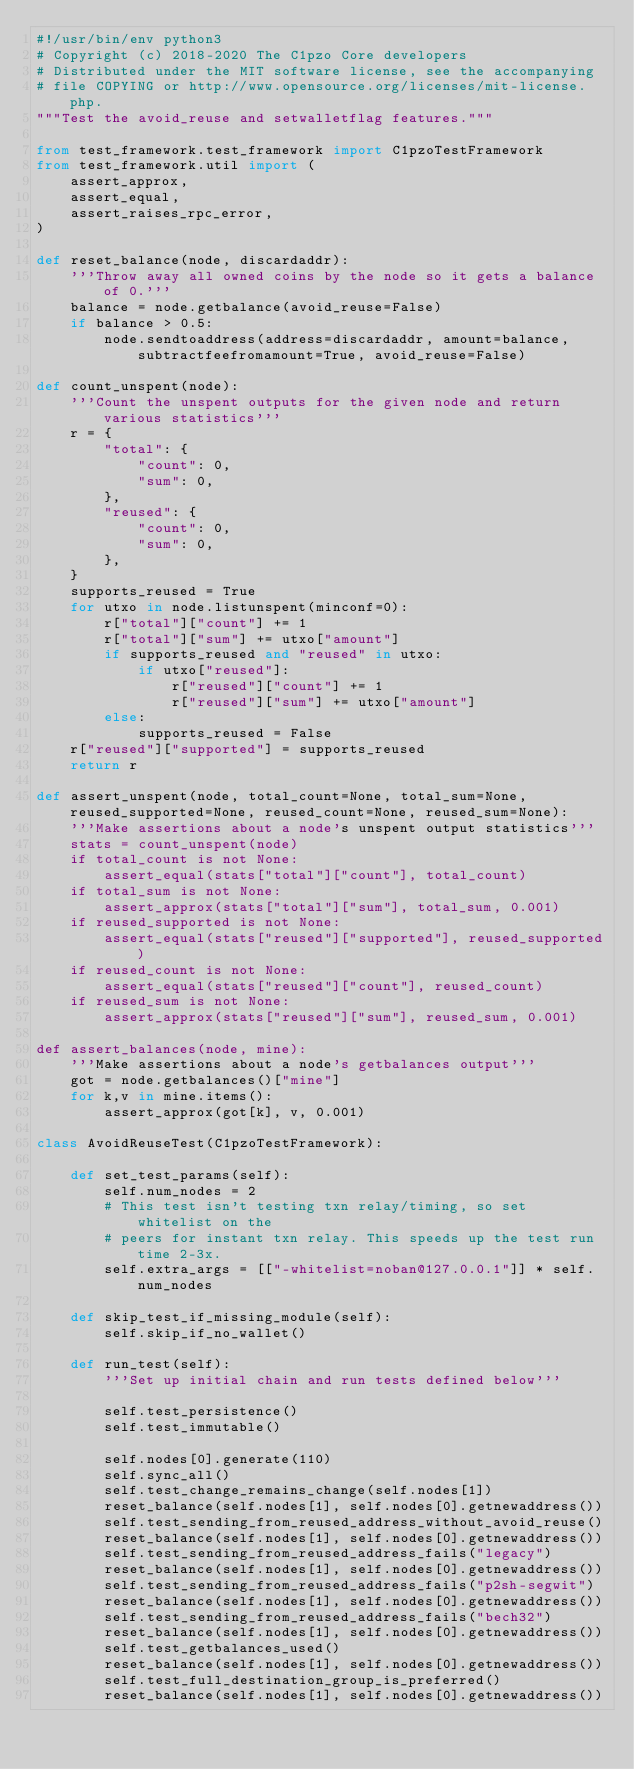<code> <loc_0><loc_0><loc_500><loc_500><_Python_>#!/usr/bin/env python3
# Copyright (c) 2018-2020 The C1pzo Core developers
# Distributed under the MIT software license, see the accompanying
# file COPYING or http://www.opensource.org/licenses/mit-license.php.
"""Test the avoid_reuse and setwalletflag features."""

from test_framework.test_framework import C1pzoTestFramework
from test_framework.util import (
    assert_approx,
    assert_equal,
    assert_raises_rpc_error,
)

def reset_balance(node, discardaddr):
    '''Throw away all owned coins by the node so it gets a balance of 0.'''
    balance = node.getbalance(avoid_reuse=False)
    if balance > 0.5:
        node.sendtoaddress(address=discardaddr, amount=balance, subtractfeefromamount=True, avoid_reuse=False)

def count_unspent(node):
    '''Count the unspent outputs for the given node and return various statistics'''
    r = {
        "total": {
            "count": 0,
            "sum": 0,
        },
        "reused": {
            "count": 0,
            "sum": 0,
        },
    }
    supports_reused = True
    for utxo in node.listunspent(minconf=0):
        r["total"]["count"] += 1
        r["total"]["sum"] += utxo["amount"]
        if supports_reused and "reused" in utxo:
            if utxo["reused"]:
                r["reused"]["count"] += 1
                r["reused"]["sum"] += utxo["amount"]
        else:
            supports_reused = False
    r["reused"]["supported"] = supports_reused
    return r

def assert_unspent(node, total_count=None, total_sum=None, reused_supported=None, reused_count=None, reused_sum=None):
    '''Make assertions about a node's unspent output statistics'''
    stats = count_unspent(node)
    if total_count is not None:
        assert_equal(stats["total"]["count"], total_count)
    if total_sum is not None:
        assert_approx(stats["total"]["sum"], total_sum, 0.001)
    if reused_supported is not None:
        assert_equal(stats["reused"]["supported"], reused_supported)
    if reused_count is not None:
        assert_equal(stats["reused"]["count"], reused_count)
    if reused_sum is not None:
        assert_approx(stats["reused"]["sum"], reused_sum, 0.001)

def assert_balances(node, mine):
    '''Make assertions about a node's getbalances output'''
    got = node.getbalances()["mine"]
    for k,v in mine.items():
        assert_approx(got[k], v, 0.001)

class AvoidReuseTest(C1pzoTestFramework):

    def set_test_params(self):
        self.num_nodes = 2
        # This test isn't testing txn relay/timing, so set whitelist on the
        # peers for instant txn relay. This speeds up the test run time 2-3x.
        self.extra_args = [["-whitelist=noban@127.0.0.1"]] * self.num_nodes

    def skip_test_if_missing_module(self):
        self.skip_if_no_wallet()

    def run_test(self):
        '''Set up initial chain and run tests defined below'''

        self.test_persistence()
        self.test_immutable()

        self.nodes[0].generate(110)
        self.sync_all()
        self.test_change_remains_change(self.nodes[1])
        reset_balance(self.nodes[1], self.nodes[0].getnewaddress())
        self.test_sending_from_reused_address_without_avoid_reuse()
        reset_balance(self.nodes[1], self.nodes[0].getnewaddress())
        self.test_sending_from_reused_address_fails("legacy")
        reset_balance(self.nodes[1], self.nodes[0].getnewaddress())
        self.test_sending_from_reused_address_fails("p2sh-segwit")
        reset_balance(self.nodes[1], self.nodes[0].getnewaddress())
        self.test_sending_from_reused_address_fails("bech32")
        reset_balance(self.nodes[1], self.nodes[0].getnewaddress())
        self.test_getbalances_used()
        reset_balance(self.nodes[1], self.nodes[0].getnewaddress())
        self.test_full_destination_group_is_preferred()
        reset_balance(self.nodes[1], self.nodes[0].getnewaddress())</code> 